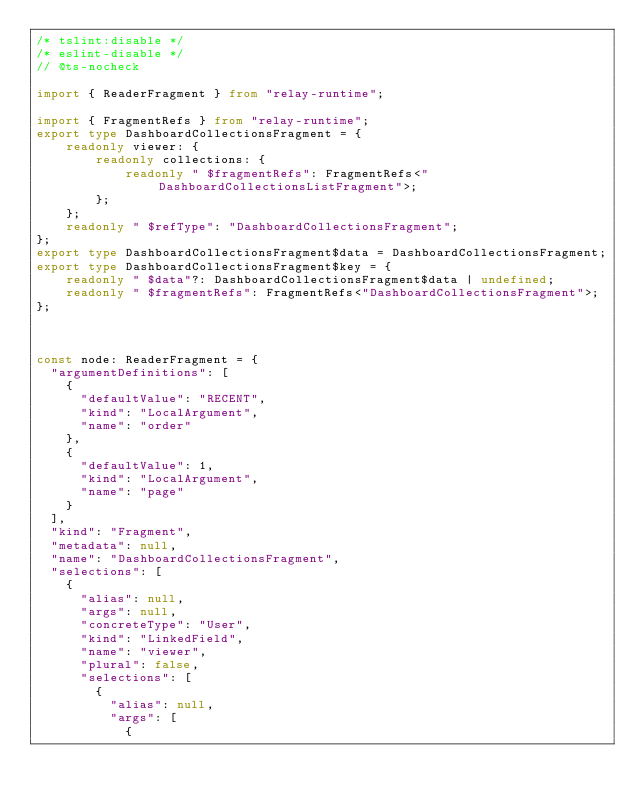<code> <loc_0><loc_0><loc_500><loc_500><_TypeScript_>/* tslint:disable */
/* eslint-disable */
// @ts-nocheck

import { ReaderFragment } from "relay-runtime";

import { FragmentRefs } from "relay-runtime";
export type DashboardCollectionsFragment = {
    readonly viewer: {
        readonly collections: {
            readonly " $fragmentRefs": FragmentRefs<"DashboardCollectionsListFragment">;
        };
    };
    readonly " $refType": "DashboardCollectionsFragment";
};
export type DashboardCollectionsFragment$data = DashboardCollectionsFragment;
export type DashboardCollectionsFragment$key = {
    readonly " $data"?: DashboardCollectionsFragment$data | undefined;
    readonly " $fragmentRefs": FragmentRefs<"DashboardCollectionsFragment">;
};



const node: ReaderFragment = {
  "argumentDefinitions": [
    {
      "defaultValue": "RECENT",
      "kind": "LocalArgument",
      "name": "order"
    },
    {
      "defaultValue": 1,
      "kind": "LocalArgument",
      "name": "page"
    }
  ],
  "kind": "Fragment",
  "metadata": null,
  "name": "DashboardCollectionsFragment",
  "selections": [
    {
      "alias": null,
      "args": null,
      "concreteType": "User",
      "kind": "LinkedField",
      "name": "viewer",
      "plural": false,
      "selections": [
        {
          "alias": null,
          "args": [
            {</code> 